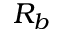Convert formula to latex. <formula><loc_0><loc_0><loc_500><loc_500>R _ { b }</formula> 